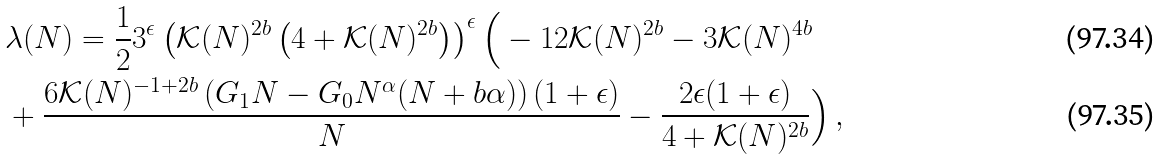Convert formula to latex. <formula><loc_0><loc_0><loc_500><loc_500>& \lambda ( N ) = \frac { 1 } { 2 } 3 ^ { \epsilon } \left ( \mathcal { K } ( N ) ^ { 2 b } \left ( 4 + \mathcal { K } ( N ) ^ { 2 b } \right ) \right ) ^ { \epsilon } \Big { ( } - 1 2 \mathcal { K } ( N ) ^ { 2 b } - 3 \mathcal { K } ( N ) ^ { 4 b } \\ & + \frac { 6 \mathcal { K } ( N ) ^ { - 1 + 2 b } \left ( G _ { 1 } N - G _ { 0 } N ^ { \alpha } ( N + b \alpha ) \right ) ( 1 + \epsilon ) } { N } - \frac { 2 \epsilon ( 1 + \epsilon ) } { 4 + \mathcal { K } ( N ) ^ { 2 b } } \Big { ) } \, ,</formula> 